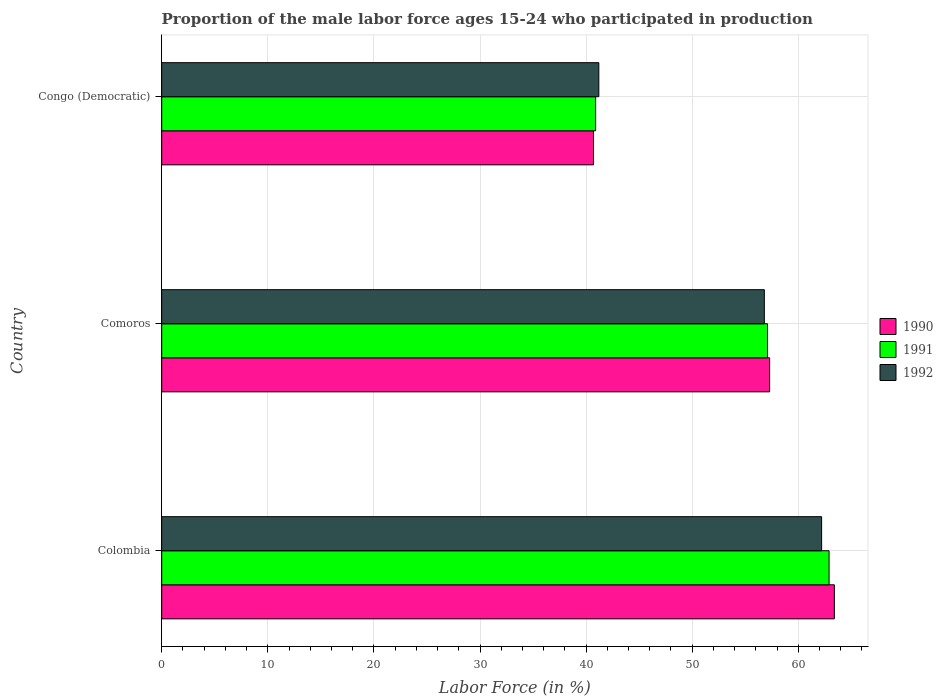How many different coloured bars are there?
Your answer should be very brief. 3. How many groups of bars are there?
Give a very brief answer. 3. Are the number of bars per tick equal to the number of legend labels?
Make the answer very short. Yes. Are the number of bars on each tick of the Y-axis equal?
Your answer should be very brief. Yes. How many bars are there on the 1st tick from the bottom?
Keep it short and to the point. 3. What is the label of the 1st group of bars from the top?
Offer a very short reply. Congo (Democratic). What is the proportion of the male labor force who participated in production in 1991 in Colombia?
Provide a short and direct response. 62.9. Across all countries, what is the maximum proportion of the male labor force who participated in production in 1992?
Provide a succinct answer. 62.2. Across all countries, what is the minimum proportion of the male labor force who participated in production in 1990?
Offer a very short reply. 40.7. In which country was the proportion of the male labor force who participated in production in 1992 minimum?
Give a very brief answer. Congo (Democratic). What is the total proportion of the male labor force who participated in production in 1992 in the graph?
Provide a succinct answer. 160.2. What is the difference between the proportion of the male labor force who participated in production in 1991 in Colombia and that in Comoros?
Your answer should be compact. 5.8. What is the difference between the proportion of the male labor force who participated in production in 1991 in Comoros and the proportion of the male labor force who participated in production in 1990 in Colombia?
Ensure brevity in your answer.  -6.3. What is the average proportion of the male labor force who participated in production in 1990 per country?
Ensure brevity in your answer.  53.8. What is the difference between the proportion of the male labor force who participated in production in 1990 and proportion of the male labor force who participated in production in 1991 in Congo (Democratic)?
Your response must be concise. -0.2. In how many countries, is the proportion of the male labor force who participated in production in 1990 greater than 4 %?
Ensure brevity in your answer.  3. What is the ratio of the proportion of the male labor force who participated in production in 1991 in Colombia to that in Comoros?
Offer a very short reply. 1.1. Is the difference between the proportion of the male labor force who participated in production in 1990 in Comoros and Congo (Democratic) greater than the difference between the proportion of the male labor force who participated in production in 1991 in Comoros and Congo (Democratic)?
Ensure brevity in your answer.  Yes. What is the difference between the highest and the second highest proportion of the male labor force who participated in production in 1990?
Provide a succinct answer. 6.1. What is the difference between the highest and the lowest proportion of the male labor force who participated in production in 1992?
Give a very brief answer. 21. In how many countries, is the proportion of the male labor force who participated in production in 1991 greater than the average proportion of the male labor force who participated in production in 1991 taken over all countries?
Ensure brevity in your answer.  2. What does the 3rd bar from the top in Comoros represents?
Keep it short and to the point. 1990. What does the 3rd bar from the bottom in Colombia represents?
Keep it short and to the point. 1992. How many bars are there?
Keep it short and to the point. 9. What is the difference between two consecutive major ticks on the X-axis?
Ensure brevity in your answer.  10. Are the values on the major ticks of X-axis written in scientific E-notation?
Ensure brevity in your answer.  No. How are the legend labels stacked?
Your answer should be compact. Vertical. What is the title of the graph?
Your answer should be very brief. Proportion of the male labor force ages 15-24 who participated in production. Does "1968" appear as one of the legend labels in the graph?
Your answer should be compact. No. What is the label or title of the X-axis?
Offer a terse response. Labor Force (in %). What is the label or title of the Y-axis?
Your answer should be compact. Country. What is the Labor Force (in %) of 1990 in Colombia?
Keep it short and to the point. 63.4. What is the Labor Force (in %) in 1991 in Colombia?
Offer a very short reply. 62.9. What is the Labor Force (in %) of 1992 in Colombia?
Keep it short and to the point. 62.2. What is the Labor Force (in %) in 1990 in Comoros?
Your answer should be very brief. 57.3. What is the Labor Force (in %) of 1991 in Comoros?
Offer a terse response. 57.1. What is the Labor Force (in %) in 1992 in Comoros?
Keep it short and to the point. 56.8. What is the Labor Force (in %) of 1990 in Congo (Democratic)?
Provide a short and direct response. 40.7. What is the Labor Force (in %) of 1991 in Congo (Democratic)?
Your answer should be very brief. 40.9. What is the Labor Force (in %) in 1992 in Congo (Democratic)?
Offer a very short reply. 41.2. Across all countries, what is the maximum Labor Force (in %) of 1990?
Your response must be concise. 63.4. Across all countries, what is the maximum Labor Force (in %) of 1991?
Your response must be concise. 62.9. Across all countries, what is the maximum Labor Force (in %) of 1992?
Offer a terse response. 62.2. Across all countries, what is the minimum Labor Force (in %) in 1990?
Provide a short and direct response. 40.7. Across all countries, what is the minimum Labor Force (in %) of 1991?
Offer a terse response. 40.9. Across all countries, what is the minimum Labor Force (in %) in 1992?
Your response must be concise. 41.2. What is the total Labor Force (in %) in 1990 in the graph?
Ensure brevity in your answer.  161.4. What is the total Labor Force (in %) of 1991 in the graph?
Give a very brief answer. 160.9. What is the total Labor Force (in %) in 1992 in the graph?
Ensure brevity in your answer.  160.2. What is the difference between the Labor Force (in %) in 1991 in Colombia and that in Comoros?
Keep it short and to the point. 5.8. What is the difference between the Labor Force (in %) of 1992 in Colombia and that in Comoros?
Provide a succinct answer. 5.4. What is the difference between the Labor Force (in %) in 1990 in Colombia and that in Congo (Democratic)?
Offer a terse response. 22.7. What is the difference between the Labor Force (in %) in 1990 in Comoros and that in Congo (Democratic)?
Your response must be concise. 16.6. What is the difference between the Labor Force (in %) in 1991 in Comoros and that in Congo (Democratic)?
Your response must be concise. 16.2. What is the difference between the Labor Force (in %) of 1992 in Comoros and that in Congo (Democratic)?
Offer a very short reply. 15.6. What is the difference between the Labor Force (in %) of 1990 in Colombia and the Labor Force (in %) of 1992 in Congo (Democratic)?
Provide a succinct answer. 22.2. What is the difference between the Labor Force (in %) in 1991 in Colombia and the Labor Force (in %) in 1992 in Congo (Democratic)?
Your answer should be very brief. 21.7. What is the difference between the Labor Force (in %) in 1990 in Comoros and the Labor Force (in %) in 1991 in Congo (Democratic)?
Keep it short and to the point. 16.4. What is the difference between the Labor Force (in %) of 1990 in Comoros and the Labor Force (in %) of 1992 in Congo (Democratic)?
Your answer should be compact. 16.1. What is the difference between the Labor Force (in %) of 1991 in Comoros and the Labor Force (in %) of 1992 in Congo (Democratic)?
Provide a succinct answer. 15.9. What is the average Labor Force (in %) of 1990 per country?
Give a very brief answer. 53.8. What is the average Labor Force (in %) in 1991 per country?
Offer a very short reply. 53.63. What is the average Labor Force (in %) of 1992 per country?
Your answer should be very brief. 53.4. What is the difference between the Labor Force (in %) in 1990 and Labor Force (in %) in 1991 in Colombia?
Your response must be concise. 0.5. What is the difference between the Labor Force (in %) of 1990 and Labor Force (in %) of 1992 in Colombia?
Provide a short and direct response. 1.2. What is the difference between the Labor Force (in %) of 1991 and Labor Force (in %) of 1992 in Colombia?
Ensure brevity in your answer.  0.7. What is the difference between the Labor Force (in %) of 1990 and Labor Force (in %) of 1991 in Comoros?
Make the answer very short. 0.2. What is the difference between the Labor Force (in %) of 1990 and Labor Force (in %) of 1992 in Comoros?
Your answer should be compact. 0.5. What is the difference between the Labor Force (in %) in 1990 and Labor Force (in %) in 1992 in Congo (Democratic)?
Your answer should be compact. -0.5. What is the ratio of the Labor Force (in %) of 1990 in Colombia to that in Comoros?
Your response must be concise. 1.11. What is the ratio of the Labor Force (in %) of 1991 in Colombia to that in Comoros?
Offer a terse response. 1.1. What is the ratio of the Labor Force (in %) in 1992 in Colombia to that in Comoros?
Provide a short and direct response. 1.1. What is the ratio of the Labor Force (in %) of 1990 in Colombia to that in Congo (Democratic)?
Offer a very short reply. 1.56. What is the ratio of the Labor Force (in %) of 1991 in Colombia to that in Congo (Democratic)?
Ensure brevity in your answer.  1.54. What is the ratio of the Labor Force (in %) of 1992 in Colombia to that in Congo (Democratic)?
Give a very brief answer. 1.51. What is the ratio of the Labor Force (in %) in 1990 in Comoros to that in Congo (Democratic)?
Keep it short and to the point. 1.41. What is the ratio of the Labor Force (in %) in 1991 in Comoros to that in Congo (Democratic)?
Your answer should be compact. 1.4. What is the ratio of the Labor Force (in %) in 1992 in Comoros to that in Congo (Democratic)?
Provide a succinct answer. 1.38. What is the difference between the highest and the second highest Labor Force (in %) of 1991?
Ensure brevity in your answer.  5.8. What is the difference between the highest and the lowest Labor Force (in %) in 1990?
Your answer should be very brief. 22.7. What is the difference between the highest and the lowest Labor Force (in %) in 1992?
Offer a terse response. 21. 